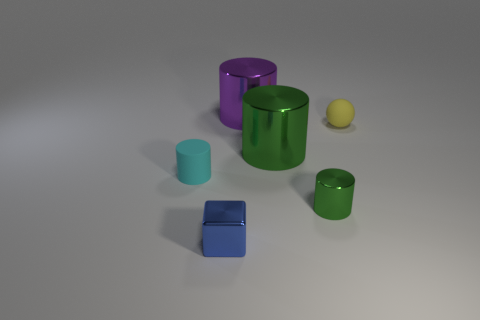Subtract 1 cylinders. How many cylinders are left? 3 Add 2 tiny cylinders. How many objects exist? 8 Subtract all cylinders. How many objects are left? 2 Subtract 0 gray spheres. How many objects are left? 6 Subtract all small cyan shiny blocks. Subtract all small blue metallic blocks. How many objects are left? 5 Add 6 tiny metallic things. How many tiny metallic things are left? 8 Add 4 shiny objects. How many shiny objects exist? 8 